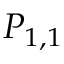Convert formula to latex. <formula><loc_0><loc_0><loc_500><loc_500>P _ { 1 , 1 }</formula> 